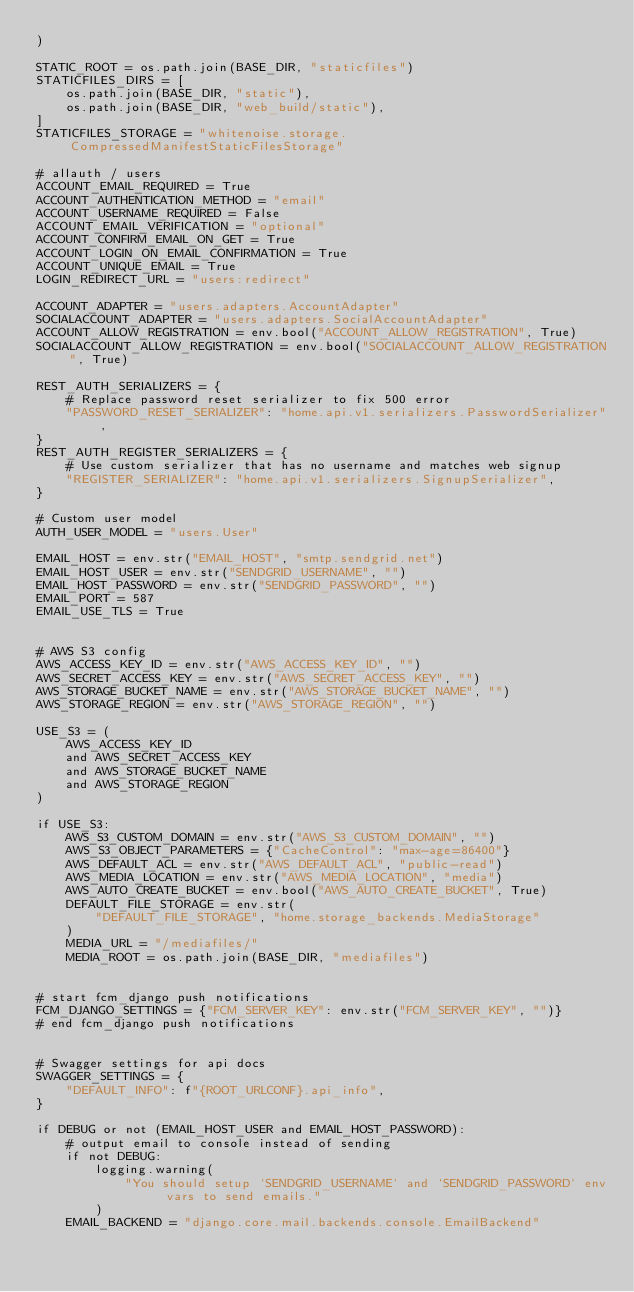<code> <loc_0><loc_0><loc_500><loc_500><_Python_>)

STATIC_ROOT = os.path.join(BASE_DIR, "staticfiles")
STATICFILES_DIRS = [
    os.path.join(BASE_DIR, "static"),
    os.path.join(BASE_DIR, "web_build/static"),
]
STATICFILES_STORAGE = "whitenoise.storage.CompressedManifestStaticFilesStorage"

# allauth / users
ACCOUNT_EMAIL_REQUIRED = True
ACCOUNT_AUTHENTICATION_METHOD = "email"
ACCOUNT_USERNAME_REQUIRED = False
ACCOUNT_EMAIL_VERIFICATION = "optional"
ACCOUNT_CONFIRM_EMAIL_ON_GET = True
ACCOUNT_LOGIN_ON_EMAIL_CONFIRMATION = True
ACCOUNT_UNIQUE_EMAIL = True
LOGIN_REDIRECT_URL = "users:redirect"

ACCOUNT_ADAPTER = "users.adapters.AccountAdapter"
SOCIALACCOUNT_ADAPTER = "users.adapters.SocialAccountAdapter"
ACCOUNT_ALLOW_REGISTRATION = env.bool("ACCOUNT_ALLOW_REGISTRATION", True)
SOCIALACCOUNT_ALLOW_REGISTRATION = env.bool("SOCIALACCOUNT_ALLOW_REGISTRATION", True)

REST_AUTH_SERIALIZERS = {
    # Replace password reset serializer to fix 500 error
    "PASSWORD_RESET_SERIALIZER": "home.api.v1.serializers.PasswordSerializer",
}
REST_AUTH_REGISTER_SERIALIZERS = {
    # Use custom serializer that has no username and matches web signup
    "REGISTER_SERIALIZER": "home.api.v1.serializers.SignupSerializer",
}

# Custom user model
AUTH_USER_MODEL = "users.User"

EMAIL_HOST = env.str("EMAIL_HOST", "smtp.sendgrid.net")
EMAIL_HOST_USER = env.str("SENDGRID_USERNAME", "")
EMAIL_HOST_PASSWORD = env.str("SENDGRID_PASSWORD", "")
EMAIL_PORT = 587
EMAIL_USE_TLS = True


# AWS S3 config
AWS_ACCESS_KEY_ID = env.str("AWS_ACCESS_KEY_ID", "")
AWS_SECRET_ACCESS_KEY = env.str("AWS_SECRET_ACCESS_KEY", "")
AWS_STORAGE_BUCKET_NAME = env.str("AWS_STORAGE_BUCKET_NAME", "")
AWS_STORAGE_REGION = env.str("AWS_STORAGE_REGION", "")

USE_S3 = (
    AWS_ACCESS_KEY_ID
    and AWS_SECRET_ACCESS_KEY
    and AWS_STORAGE_BUCKET_NAME
    and AWS_STORAGE_REGION
)

if USE_S3:
    AWS_S3_CUSTOM_DOMAIN = env.str("AWS_S3_CUSTOM_DOMAIN", "")
    AWS_S3_OBJECT_PARAMETERS = {"CacheControl": "max-age=86400"}
    AWS_DEFAULT_ACL = env.str("AWS_DEFAULT_ACL", "public-read")
    AWS_MEDIA_LOCATION = env.str("AWS_MEDIA_LOCATION", "media")
    AWS_AUTO_CREATE_BUCKET = env.bool("AWS_AUTO_CREATE_BUCKET", True)
    DEFAULT_FILE_STORAGE = env.str(
        "DEFAULT_FILE_STORAGE", "home.storage_backends.MediaStorage"
    )
    MEDIA_URL = "/mediafiles/"
    MEDIA_ROOT = os.path.join(BASE_DIR, "mediafiles")


# start fcm_django push notifications
FCM_DJANGO_SETTINGS = {"FCM_SERVER_KEY": env.str("FCM_SERVER_KEY", "")}
# end fcm_django push notifications


# Swagger settings for api docs
SWAGGER_SETTINGS = {
    "DEFAULT_INFO": f"{ROOT_URLCONF}.api_info",
}

if DEBUG or not (EMAIL_HOST_USER and EMAIL_HOST_PASSWORD):
    # output email to console instead of sending
    if not DEBUG:
        logging.warning(
            "You should setup `SENDGRID_USERNAME` and `SENDGRID_PASSWORD` env vars to send emails."
        )
    EMAIL_BACKEND = "django.core.mail.backends.console.EmailBackend"
</code> 